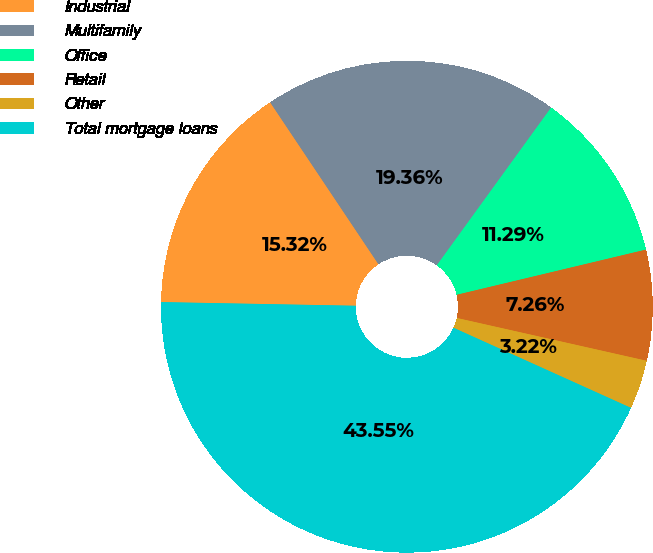Convert chart to OTSL. <chart><loc_0><loc_0><loc_500><loc_500><pie_chart><fcel>Industrial<fcel>Multifamily<fcel>Office<fcel>Retail<fcel>Other<fcel>Total mortgage loans<nl><fcel>15.32%<fcel>19.36%<fcel>11.29%<fcel>7.26%<fcel>3.22%<fcel>43.55%<nl></chart> 